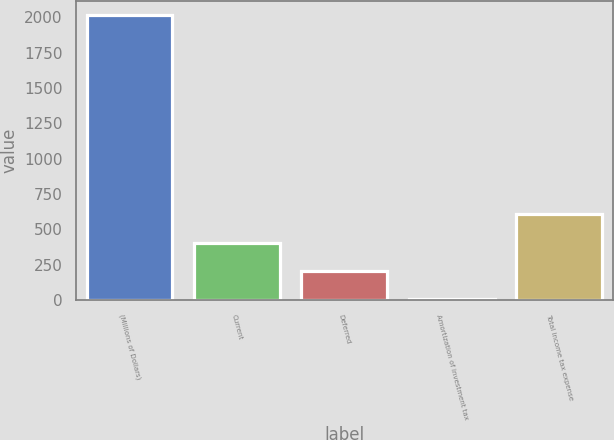Convert chart. <chart><loc_0><loc_0><loc_500><loc_500><bar_chart><fcel>(Millions of Dollars)<fcel>Current<fcel>Deferred<fcel>Amortization of investment tax<fcel>Total income tax expense<nl><fcel>2014<fcel>406.8<fcel>205.9<fcel>5<fcel>607.7<nl></chart> 